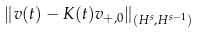<formula> <loc_0><loc_0><loc_500><loc_500>\left \| v ( t ) - K ( t ) v _ { + , 0 } \right \| _ { ( H ^ { s } , H ^ { s - 1 } ) }</formula> 